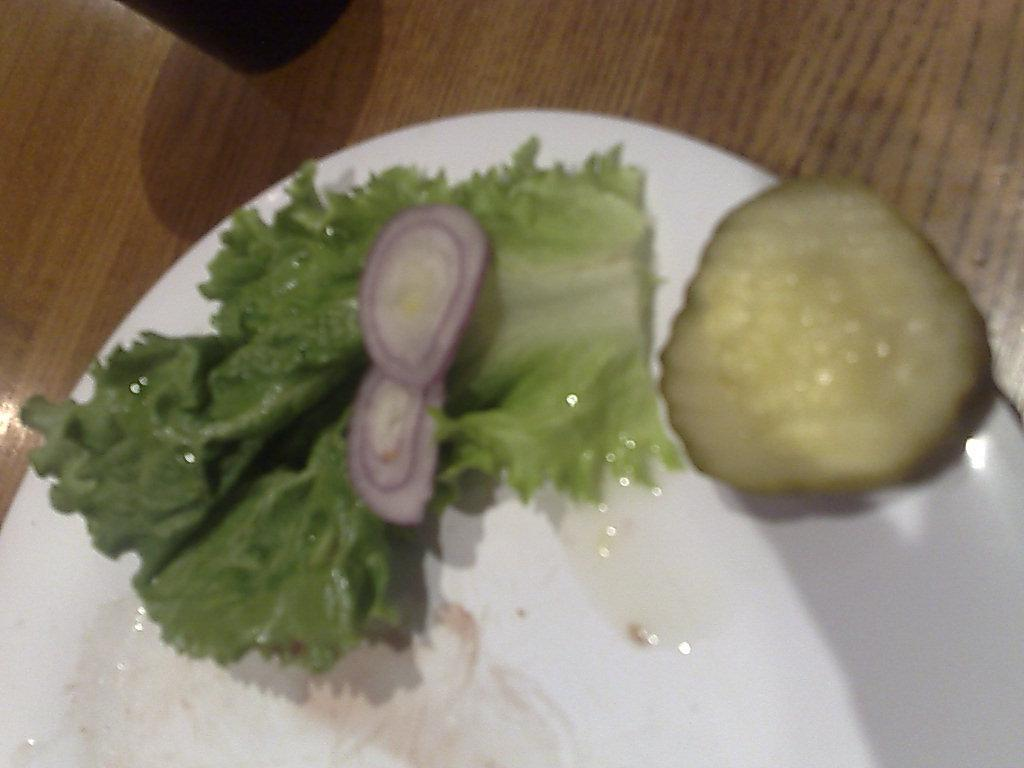What piece of furniture is present in the image? There is a table in the image. What is placed on the table? There is a plate on the table. What food items are on the plate? There are onion slices and leafy vegetable on the plate. What type of container is visible at the top of the image? There is a cup visible at the top of the image. How does the magic affect the onion slices on the plate? There is no magic present in the image, so it cannot affect the onion slices. 